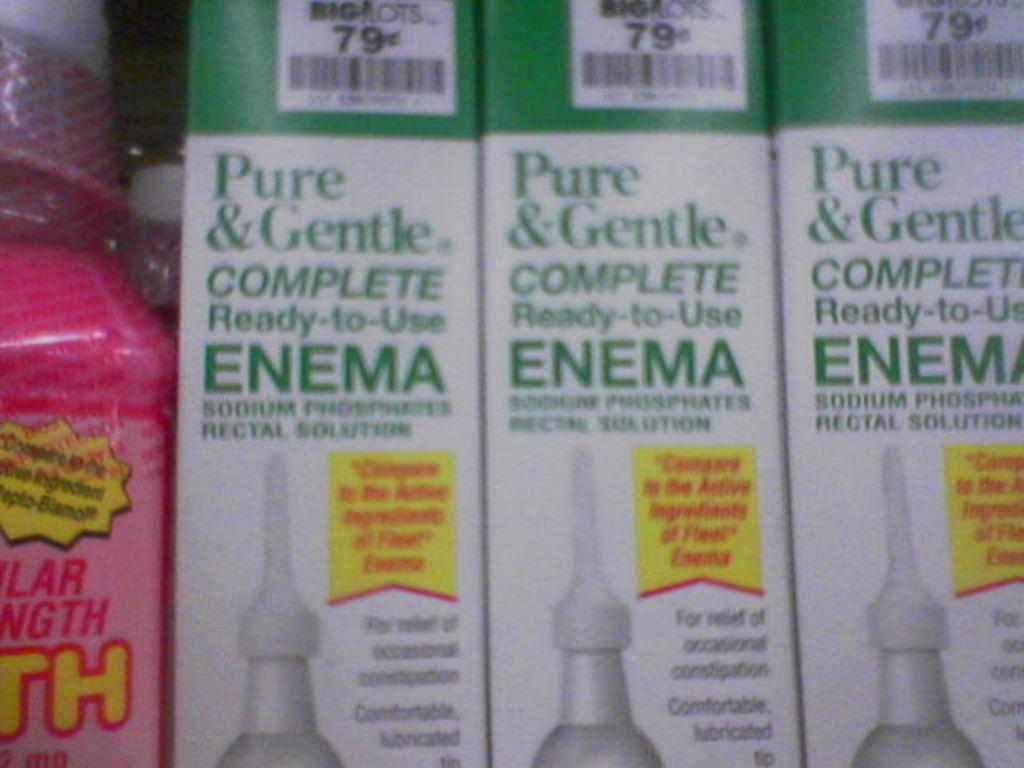Provide a one-sentence caption for the provided image. Three packages of 79 cent enemas for sale.. 